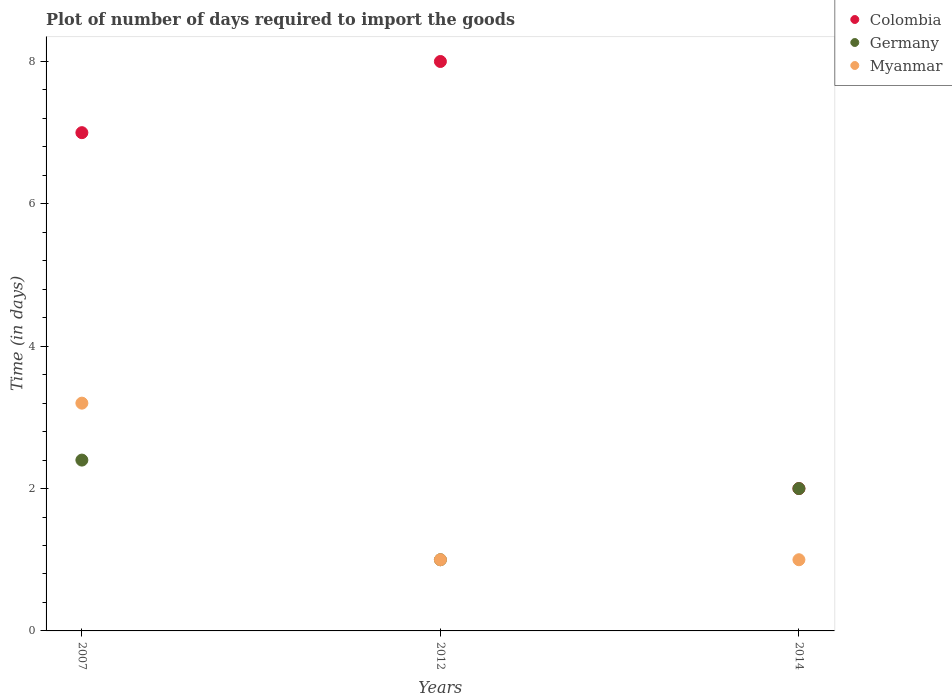Across all years, what is the maximum time required to import goods in Germany?
Your response must be concise. 2.4. In which year was the time required to import goods in Germany minimum?
Offer a terse response. 2012. What is the total time required to import goods in Colombia in the graph?
Your answer should be compact. 17. What is the average time required to import goods in Myanmar per year?
Ensure brevity in your answer.  1.73. In the year 2007, what is the difference between the time required to import goods in Colombia and time required to import goods in Myanmar?
Keep it short and to the point. 3.8. In how many years, is the time required to import goods in Colombia greater than 2.4 days?
Ensure brevity in your answer.  2. What is the ratio of the time required to import goods in Germany in 2007 to that in 2014?
Your response must be concise. 1.2. Is the time required to import goods in Germany in 2007 less than that in 2012?
Offer a terse response. No. Is the difference between the time required to import goods in Colombia in 2007 and 2014 greater than the difference between the time required to import goods in Myanmar in 2007 and 2014?
Give a very brief answer. Yes. What is the difference between the highest and the second highest time required to import goods in Germany?
Provide a short and direct response. 0.4. Does the time required to import goods in Colombia monotonically increase over the years?
Make the answer very short. No. Is the time required to import goods in Myanmar strictly greater than the time required to import goods in Colombia over the years?
Keep it short and to the point. No. How many years are there in the graph?
Your answer should be very brief. 3. Does the graph contain any zero values?
Your answer should be compact. No. What is the title of the graph?
Make the answer very short. Plot of number of days required to import the goods. Does "Tunisia" appear as one of the legend labels in the graph?
Offer a very short reply. No. What is the label or title of the X-axis?
Keep it short and to the point. Years. What is the label or title of the Y-axis?
Offer a very short reply. Time (in days). What is the Time (in days) in Germany in 2007?
Provide a short and direct response. 2.4. What is the Time (in days) of Myanmar in 2014?
Ensure brevity in your answer.  1. Across all years, what is the maximum Time (in days) in Colombia?
Provide a short and direct response. 8. Across all years, what is the maximum Time (in days) in Germany?
Give a very brief answer. 2.4. Across all years, what is the maximum Time (in days) in Myanmar?
Provide a short and direct response. 3.2. Across all years, what is the minimum Time (in days) of Colombia?
Keep it short and to the point. 2. Across all years, what is the minimum Time (in days) in Myanmar?
Keep it short and to the point. 1. What is the total Time (in days) of Germany in the graph?
Your answer should be compact. 5.4. What is the total Time (in days) of Myanmar in the graph?
Provide a short and direct response. 5.2. What is the difference between the Time (in days) in Colombia in 2007 and that in 2012?
Keep it short and to the point. -1. What is the difference between the Time (in days) of Germany in 2007 and that in 2012?
Your answer should be very brief. 1.4. What is the difference between the Time (in days) in Myanmar in 2007 and that in 2012?
Give a very brief answer. 2.2. What is the difference between the Time (in days) of Germany in 2012 and that in 2014?
Offer a terse response. -1. What is the difference between the Time (in days) of Myanmar in 2012 and that in 2014?
Your response must be concise. 0. What is the difference between the Time (in days) of Colombia in 2007 and the Time (in days) of Germany in 2012?
Offer a very short reply. 6. What is the difference between the Time (in days) in Germany in 2007 and the Time (in days) in Myanmar in 2012?
Your answer should be very brief. 1.4. What is the difference between the Time (in days) of Colombia in 2007 and the Time (in days) of Myanmar in 2014?
Your response must be concise. 6. What is the average Time (in days) in Colombia per year?
Make the answer very short. 5.67. What is the average Time (in days) of Myanmar per year?
Provide a succinct answer. 1.73. In the year 2007, what is the difference between the Time (in days) in Colombia and Time (in days) in Germany?
Your response must be concise. 4.6. In the year 2007, what is the difference between the Time (in days) of Colombia and Time (in days) of Myanmar?
Give a very brief answer. 3.8. In the year 2007, what is the difference between the Time (in days) in Germany and Time (in days) in Myanmar?
Keep it short and to the point. -0.8. In the year 2012, what is the difference between the Time (in days) in Colombia and Time (in days) in Myanmar?
Keep it short and to the point. 7. In the year 2014, what is the difference between the Time (in days) in Colombia and Time (in days) in Germany?
Keep it short and to the point. 0. In the year 2014, what is the difference between the Time (in days) of Colombia and Time (in days) of Myanmar?
Make the answer very short. 1. In the year 2014, what is the difference between the Time (in days) in Germany and Time (in days) in Myanmar?
Offer a terse response. 1. What is the ratio of the Time (in days) in Colombia in 2007 to that in 2012?
Your answer should be very brief. 0.88. What is the ratio of the Time (in days) of Myanmar in 2007 to that in 2014?
Give a very brief answer. 3.2. What is the ratio of the Time (in days) in Colombia in 2012 to that in 2014?
Provide a short and direct response. 4. What is the ratio of the Time (in days) of Germany in 2012 to that in 2014?
Provide a short and direct response. 0.5. What is the difference between the highest and the second highest Time (in days) of Myanmar?
Your answer should be compact. 2.2. 